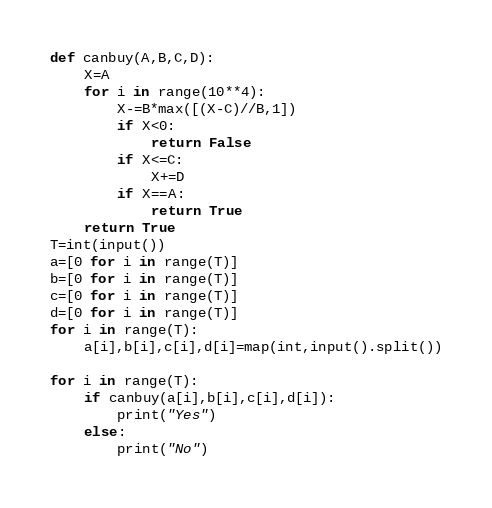Convert code to text. <code><loc_0><loc_0><loc_500><loc_500><_Python_>def canbuy(A,B,C,D):
    X=A
    for i in range(10**4):
        X-=B*max([(X-C)//B,1])
        if X<0:
            return False
        if X<=C:
            X+=D
        if X==A:
            return True
    return True
T=int(input())
a=[0 for i in range(T)]
b=[0 for i in range(T)]
c=[0 for i in range(T)]
d=[0 for i in range(T)]
for i in range(T):
    a[i],b[i],c[i],d[i]=map(int,input().split())

for i in range(T):
    if canbuy(a[i],b[i],c[i],d[i]):
        print("Yes")
    else:
        print("No")
</code> 